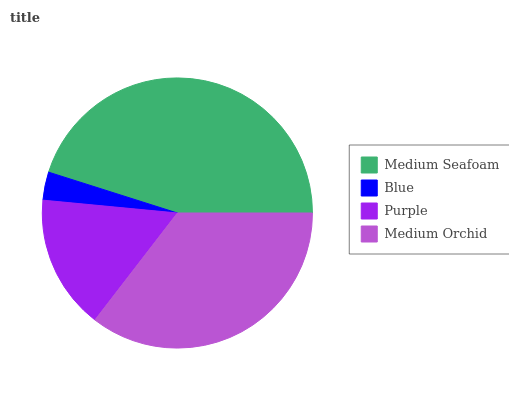Is Blue the minimum?
Answer yes or no. Yes. Is Medium Seafoam the maximum?
Answer yes or no. Yes. Is Purple the minimum?
Answer yes or no. No. Is Purple the maximum?
Answer yes or no. No. Is Purple greater than Blue?
Answer yes or no. Yes. Is Blue less than Purple?
Answer yes or no. Yes. Is Blue greater than Purple?
Answer yes or no. No. Is Purple less than Blue?
Answer yes or no. No. Is Medium Orchid the high median?
Answer yes or no. Yes. Is Purple the low median?
Answer yes or no. Yes. Is Blue the high median?
Answer yes or no. No. Is Medium Orchid the low median?
Answer yes or no. No. 